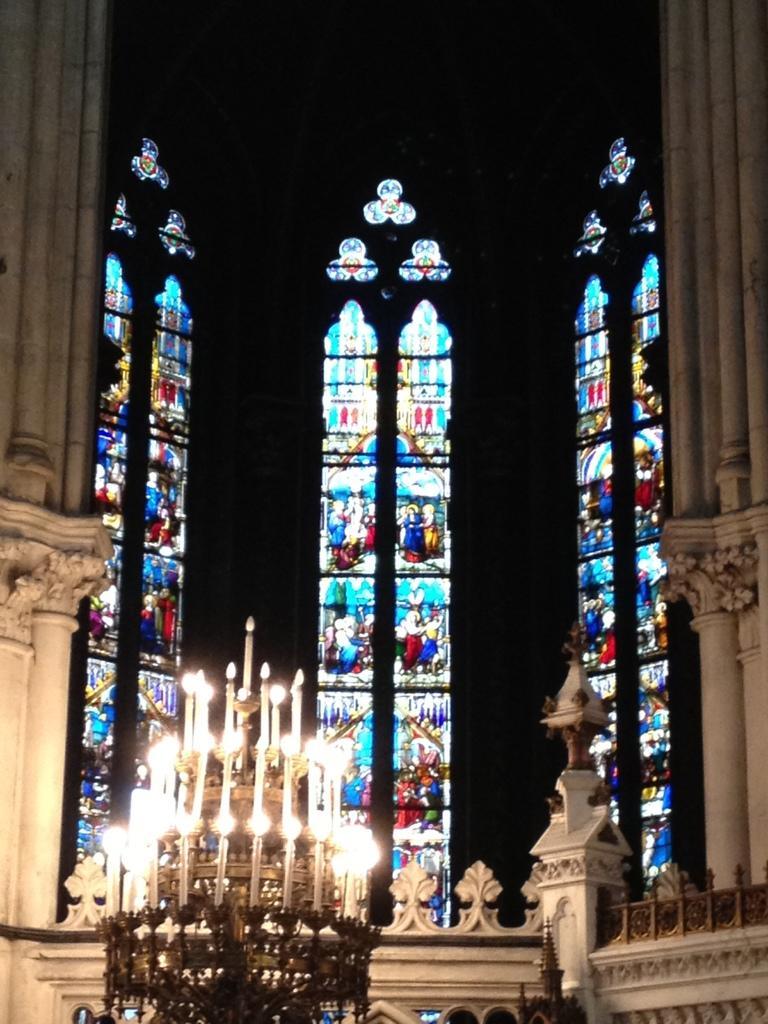Describe this image in one or two sentences. This picture is an inside view of a building. At the bottom of the image we can see the candle lights with stand. In the background of the image we can see the glasses, pillars. On the glasses we can see the painting of the pictures. 